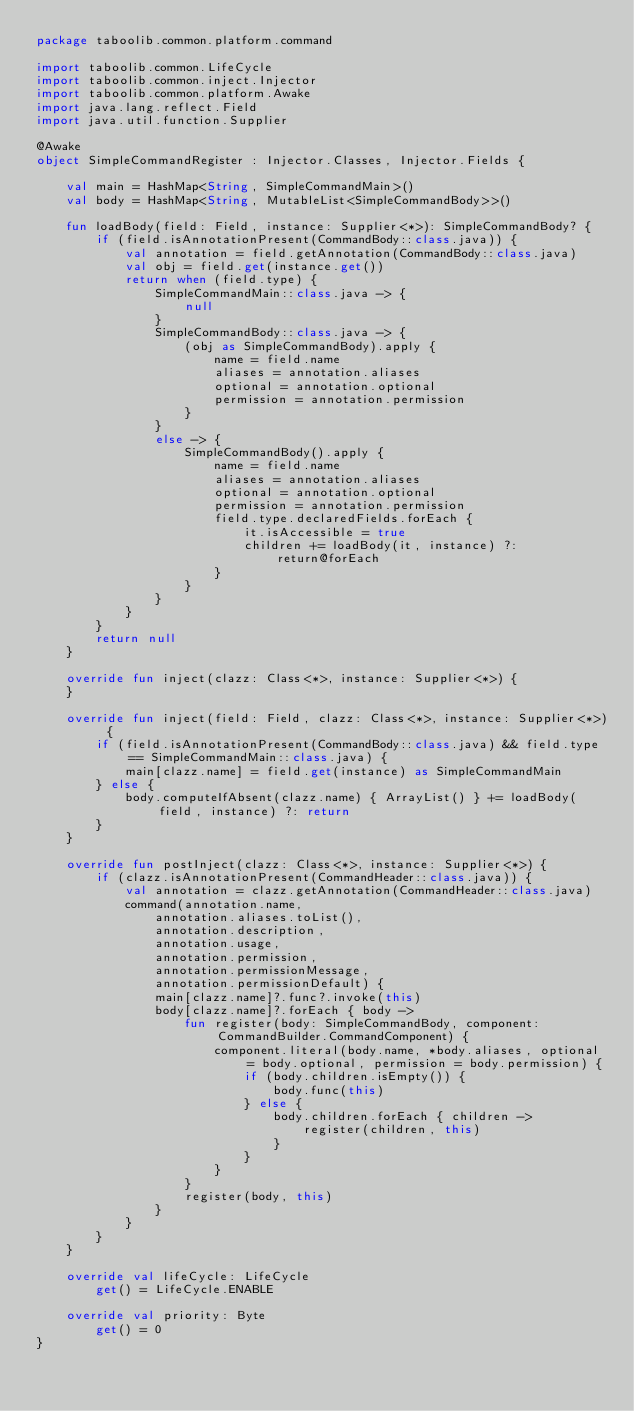Convert code to text. <code><loc_0><loc_0><loc_500><loc_500><_Kotlin_>package taboolib.common.platform.command

import taboolib.common.LifeCycle
import taboolib.common.inject.Injector
import taboolib.common.platform.Awake
import java.lang.reflect.Field
import java.util.function.Supplier

@Awake
object SimpleCommandRegister : Injector.Classes, Injector.Fields {

    val main = HashMap<String, SimpleCommandMain>()
    val body = HashMap<String, MutableList<SimpleCommandBody>>()

    fun loadBody(field: Field, instance: Supplier<*>): SimpleCommandBody? {
        if (field.isAnnotationPresent(CommandBody::class.java)) {
            val annotation = field.getAnnotation(CommandBody::class.java)
            val obj = field.get(instance.get())
            return when (field.type) {
                SimpleCommandMain::class.java -> {
                    null
                }
                SimpleCommandBody::class.java -> {
                    (obj as SimpleCommandBody).apply {
                        name = field.name
                        aliases = annotation.aliases
                        optional = annotation.optional
                        permission = annotation.permission
                    }
                }
                else -> {
                    SimpleCommandBody().apply {
                        name = field.name
                        aliases = annotation.aliases
                        optional = annotation.optional
                        permission = annotation.permission
                        field.type.declaredFields.forEach {
                            it.isAccessible = true
                            children += loadBody(it, instance) ?: return@forEach
                        }
                    }
                }
            }
        }
        return null
    }

    override fun inject(clazz: Class<*>, instance: Supplier<*>) {
    }

    override fun inject(field: Field, clazz: Class<*>, instance: Supplier<*>) {
        if (field.isAnnotationPresent(CommandBody::class.java) && field.type == SimpleCommandMain::class.java) {
            main[clazz.name] = field.get(instance) as SimpleCommandMain
        } else {
            body.computeIfAbsent(clazz.name) { ArrayList() } += loadBody(field, instance) ?: return
        }
    }

    override fun postInject(clazz: Class<*>, instance: Supplier<*>) {
        if (clazz.isAnnotationPresent(CommandHeader::class.java)) {
            val annotation = clazz.getAnnotation(CommandHeader::class.java)
            command(annotation.name,
                annotation.aliases.toList(),
                annotation.description,
                annotation.usage,
                annotation.permission,
                annotation.permissionMessage,
                annotation.permissionDefault) {
                main[clazz.name]?.func?.invoke(this)
                body[clazz.name]?.forEach { body ->
                    fun register(body: SimpleCommandBody, component: CommandBuilder.CommandComponent) {
                        component.literal(body.name, *body.aliases, optional = body.optional, permission = body.permission) {
                            if (body.children.isEmpty()) {
                                body.func(this)
                            } else {
                                body.children.forEach { children ->
                                    register(children, this)
                                }
                            }
                        }
                    }
                    register(body, this)
                }
            }
        }
    }

    override val lifeCycle: LifeCycle
        get() = LifeCycle.ENABLE

    override val priority: Byte
        get() = 0
}</code> 